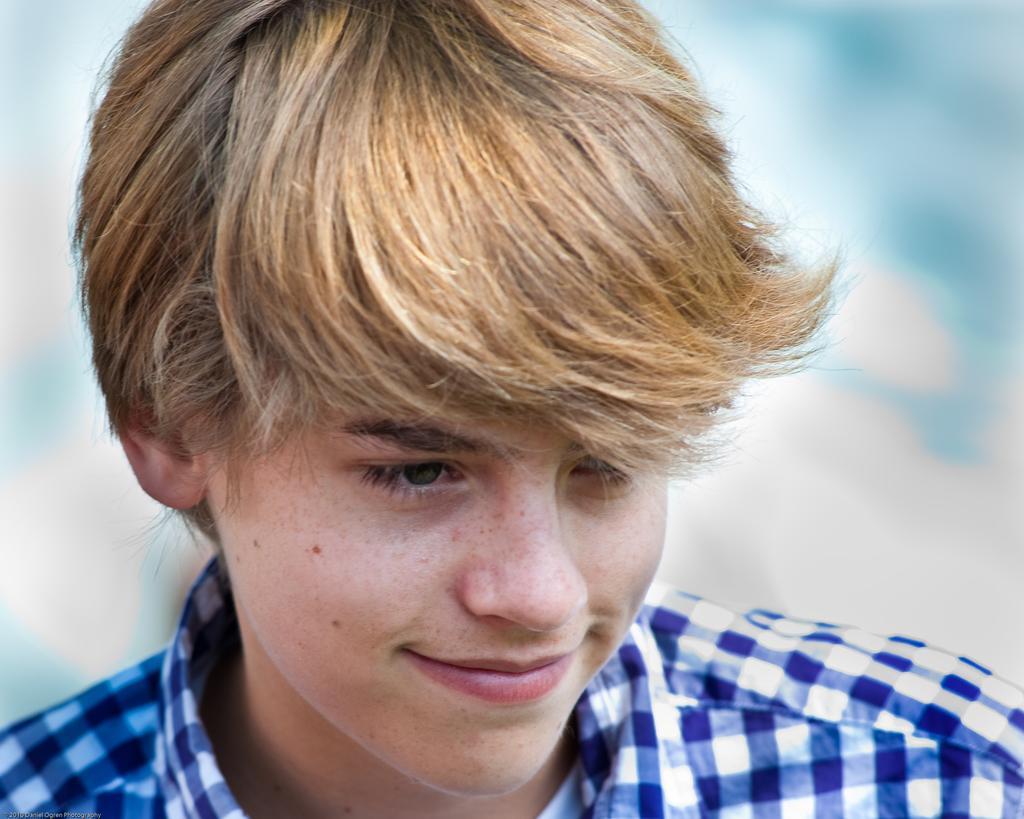Could you give a brief overview of what you see in this image? In this picture I can see a man and I can see a blurry background. 